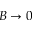<formula> <loc_0><loc_0><loc_500><loc_500>B \to 0</formula> 